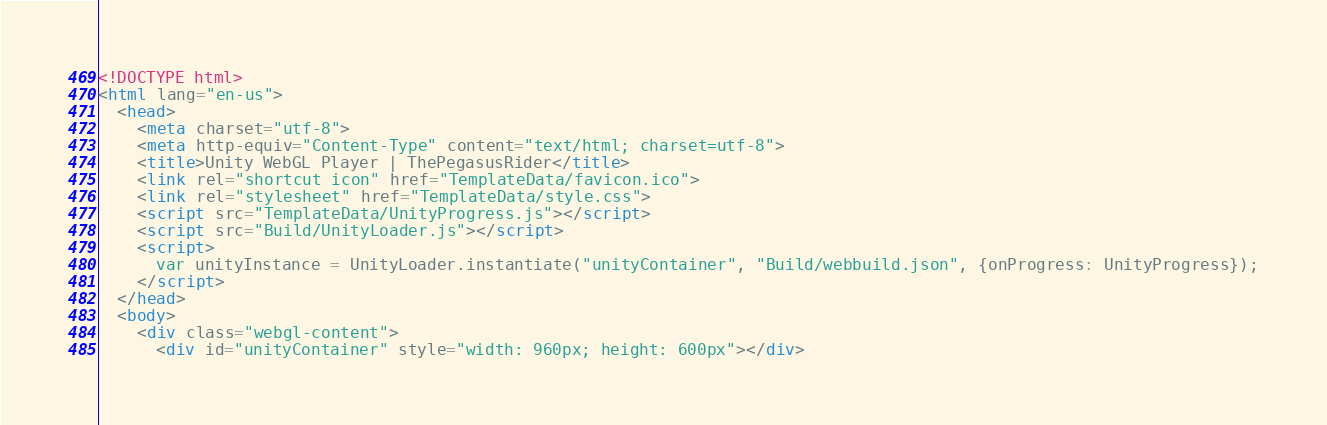Convert code to text. <code><loc_0><loc_0><loc_500><loc_500><_HTML_><!DOCTYPE html>
<html lang="en-us">
  <head>
    <meta charset="utf-8">
    <meta http-equiv="Content-Type" content="text/html; charset=utf-8">
    <title>Unity WebGL Player | ThePegasusRider</title>
    <link rel="shortcut icon" href="TemplateData/favicon.ico">
    <link rel="stylesheet" href="TemplateData/style.css">
    <script src="TemplateData/UnityProgress.js"></script>
    <script src="Build/UnityLoader.js"></script>
    <script>
      var unityInstance = UnityLoader.instantiate("unityContainer", "Build/webbuild.json", {onProgress: UnityProgress});
    </script>
  </head>
  <body>
    <div class="webgl-content">
      <div id="unityContainer" style="width: 960px; height: 600px"></div></code> 